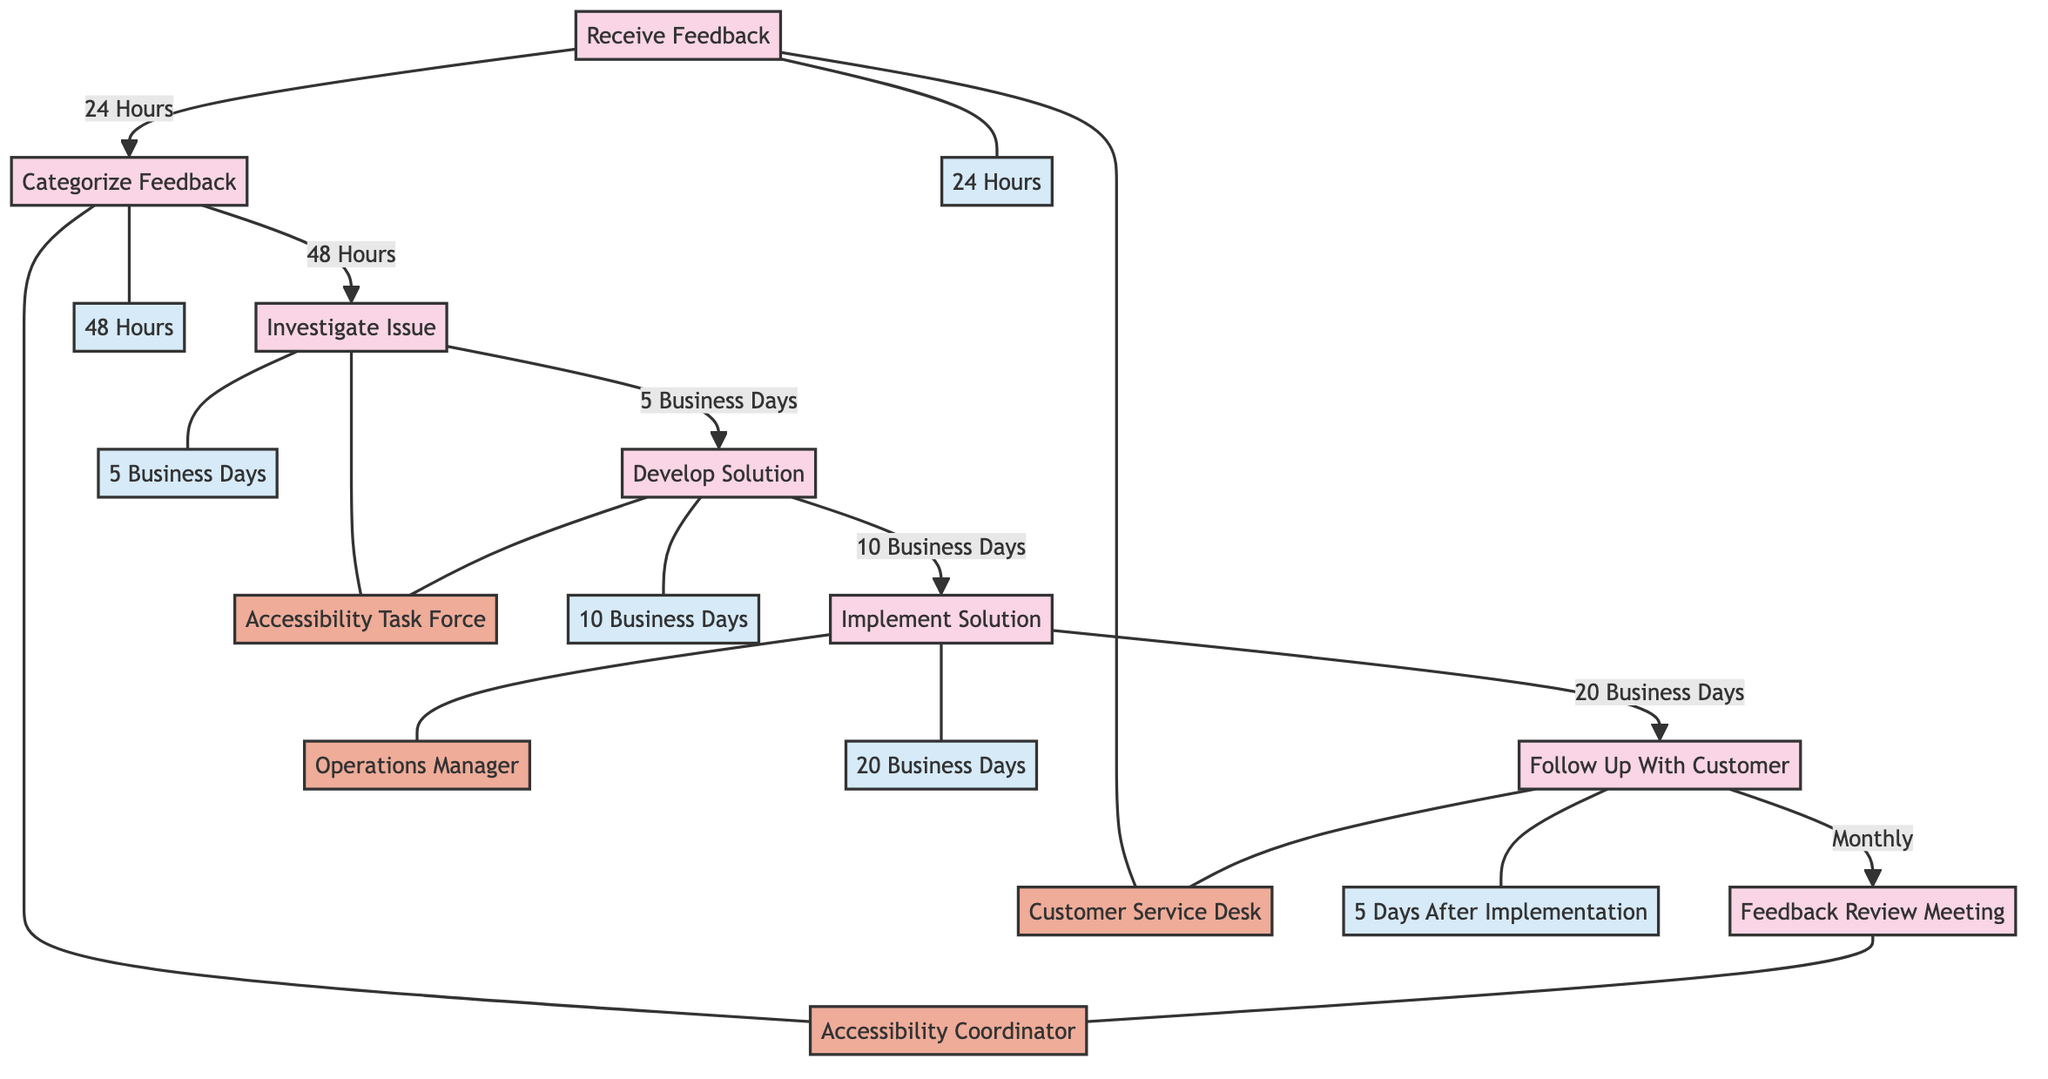What is the initial response time for receiving feedback? The diagram specifies that the "InitialResponseTime" for the "ReceiveFeedback" process is "Within 24 Hours".
Answer: Within 24 Hours Who is responsible for categorizing feedback? According to the diagram, the "ResponsibleEntity" for "CategorizeFeedback" is the "Accessibility Coordinator".
Answer: Accessibility Coordinator How many methods are used for receiving feedback? The "ReceiveFeedback" node lists five methods: Phone, Email, In-Store Form, Website Form, and Social Media. Therefore, there are five methods in total.
Answer: 5 What is the timeframe for investigating an issue? The diagram states that the "InvestigationTimeFrame" for "InvestigateIssue" is "5 Business Days".
Answer: 5 Business Days Which entity is responsible for following up with customers? The diagram indicates that the "ResponsibleEntity" for "FollowUpWithCustomer" is the "Customer Service Desk".
Answer: Customer Service Desk What types of feedback are categorized in the process? The "CategorizeFeedback" section lists four categories: Physical Accessibility, Sensory Accessibility, Digital Accessibility, and Customer Service.
Answer: 4 What is the total time taken from receiving feedback to following up with the customer? To find this, add the timeframes for each step: 24 hours (1 day) + 48 hours (2 days) + 5 business days + 10 business days + 20 business days. This totals approximately 39 business days.
Answer: 39 business days In which order do the processes occur after receiving feedback? The sequence shown in the diagram is: Receive Feedback → Categorize Feedback → Investigate Issue → Develop Solution → Implement Solution → Follow Up With Customer.
Answer: Receive Feedback, Categorize Feedback, Investigate Issue, Develop Solution, Implement Solution, Follow Up With Customer How often does the feedback review meeting occur? The diagram specifies that the "Frequency" of the "Feedback Review Meeting" is "Monthly".
Answer: Monthly 